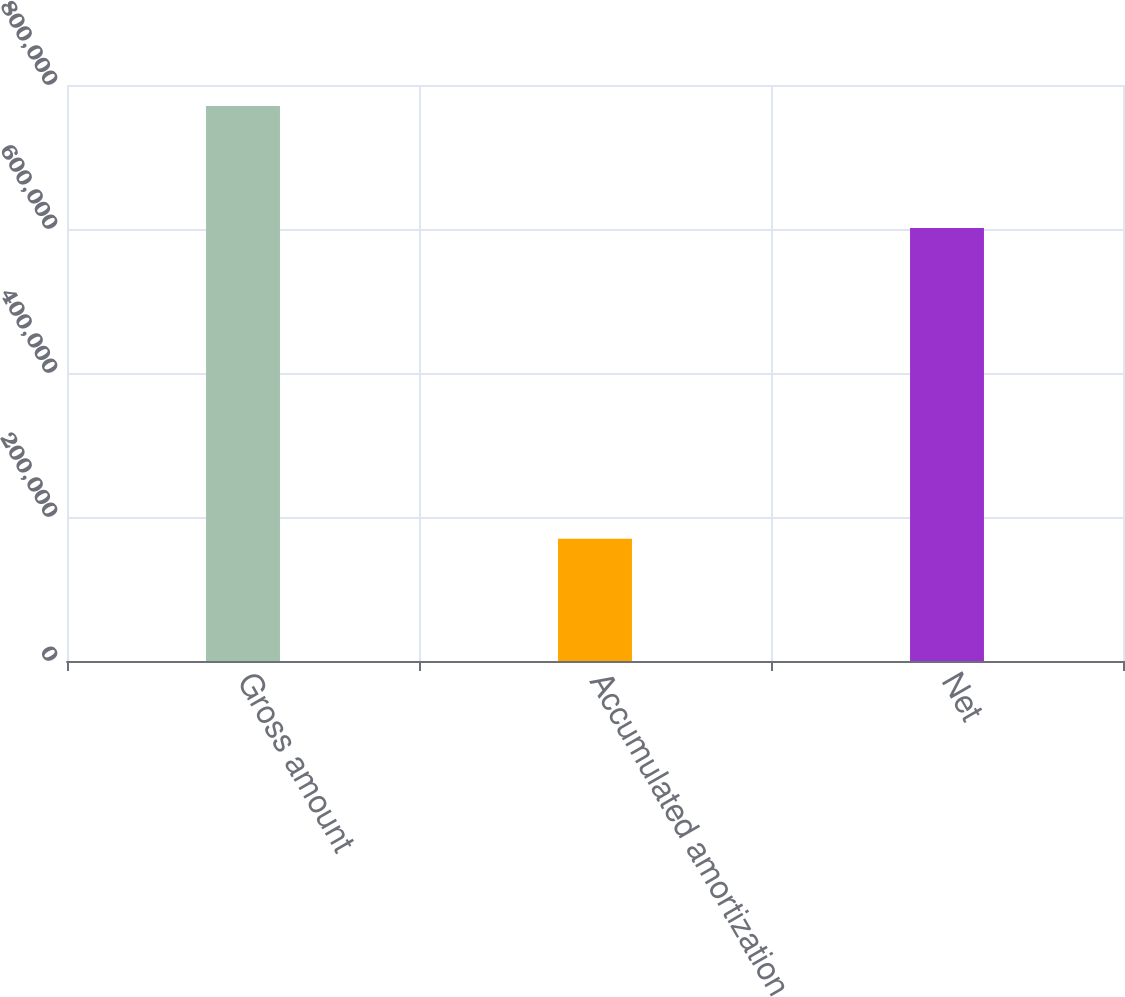Convert chart. <chart><loc_0><loc_0><loc_500><loc_500><bar_chart><fcel>Gross amount<fcel>Accumulated amortization<fcel>Net<nl><fcel>770855<fcel>169623<fcel>601232<nl></chart> 